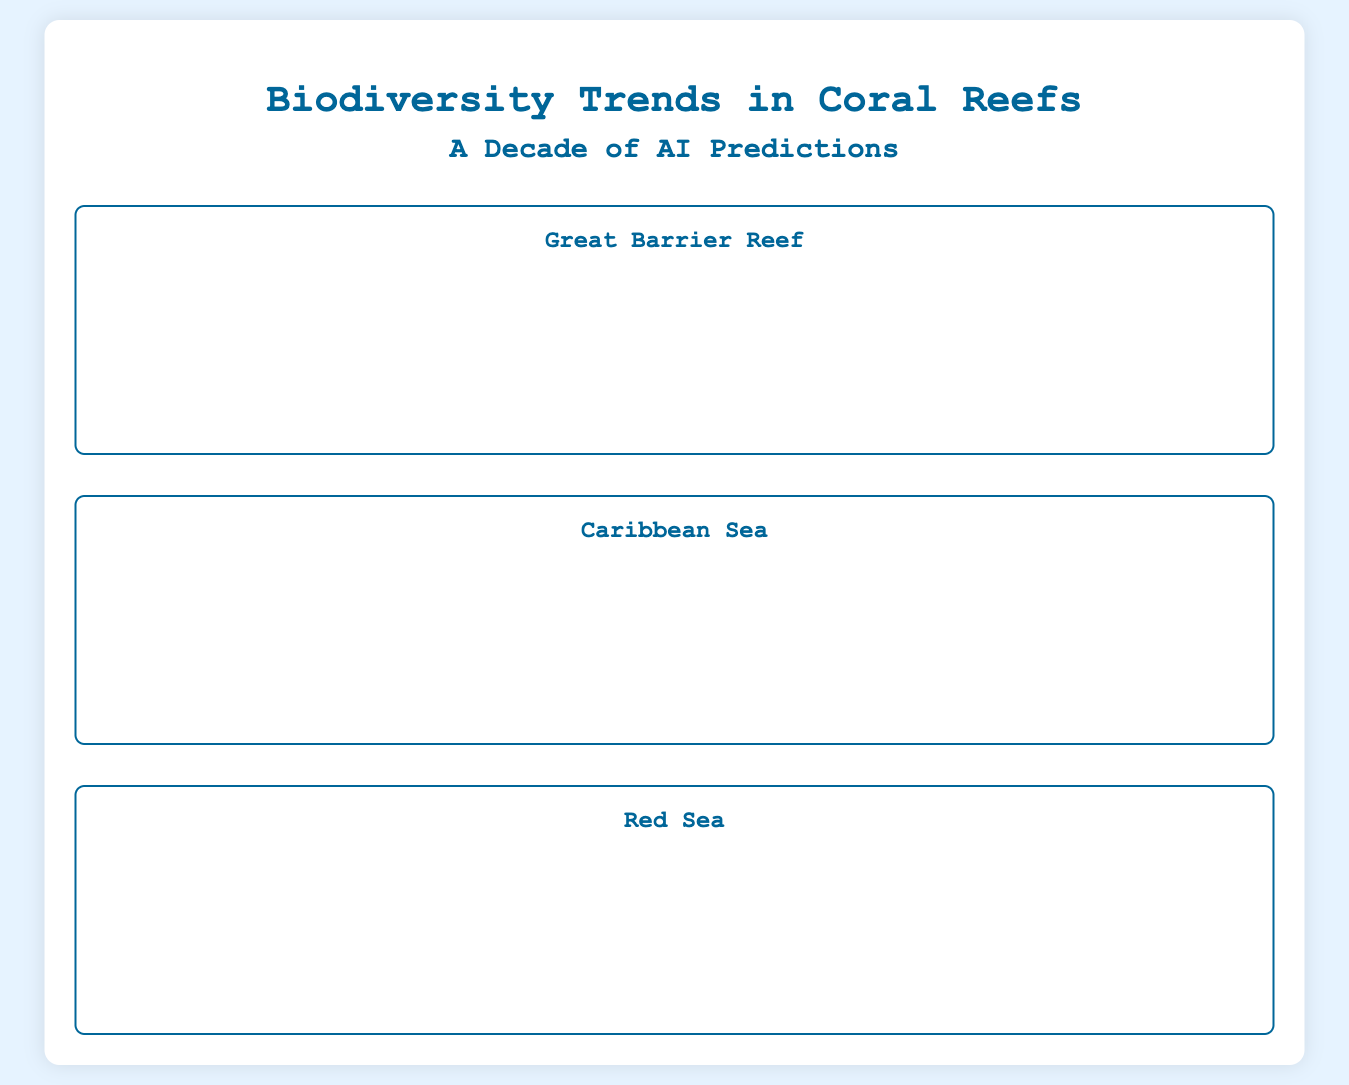what is the highest biodiversity index recorded in the Great Barrier Reef? The highest biodiversity index recorded in the Great Barrier Reef was 0.85 in 2013.
Answer: 0.85 what year did the Caribbean Sea have its lowest biodiversity index? The lowest biodiversity index in the Caribbean Sea occurred in 2022 with a value of 0.55.
Answer: 2022 how many coral species were recorded in the Red Sea in 2019? The Red Sea had 220 coral species recorded in 2019.
Answer: 220 what was the trend in coral population in the Great Barrier Reef from 2013 to 2022? The trend in coral population in the Great Barrier Reef showed a steady decline from 200 to 130 from 2013 to 2022.
Answer: Decline how many fish species were recorded in the Caribbean Sea in 2021? The Caribbean Sea recorded 2100 fish species in 2021.
Answer: 2100 which location had the highest percentage of biodiversity index in 2013? The Red Sea had the highest percentage of biodiversity index in 2013 at 0.90.
Answer: Red Sea what is the color representing a biodiversity index of 0.75 on the heatmap? A biodiversity index of 0.75 would be represented by a shade of yellow-green on the heatmap.
Answer: Yellow-green how many crustacean species are represented in the Red Sea data for 2018? In 2018, the Red Sea represented 500 crustacean species.
Answer: 500 in which year did the species population of fish in the Great Barrier Reef first drop below 2500? The fish population in the Great Barrier Reef first dropped below 2500 in 2019.
Answer: 2019 